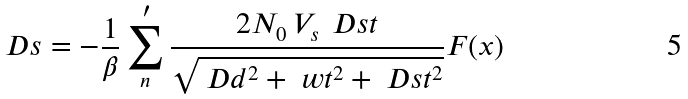<formula> <loc_0><loc_0><loc_500><loc_500>\ D s = - \frac { 1 } { \beta } \sum _ { n } ^ { \, \prime } \frac { 2 N _ { 0 } \, V _ { s } \, \ D s t } { \sqrt { \ D d ^ { 2 } + \ w t ^ { 2 } + \ D s t ^ { 2 } } } F ( x )</formula> 